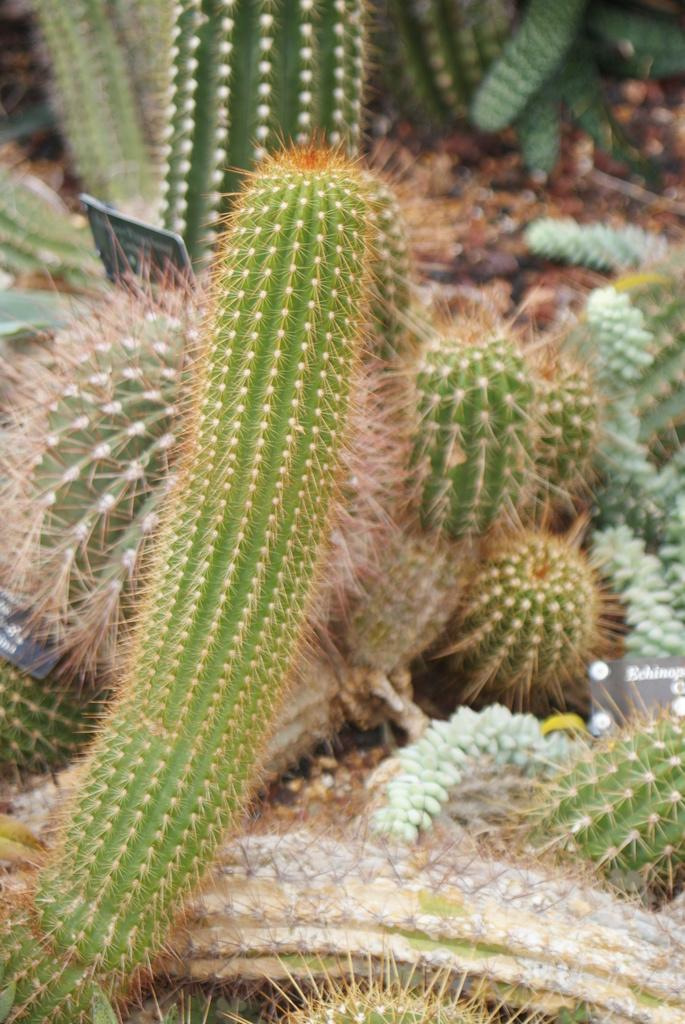What type of plants are in the image? There are cactus plants in the image. What else can be seen in the image besides the cactus plants? There is a small board with some text in the image. What type of soap is being used to clean the cactus plants in the image? There is no soap or cleaning activity depicted in the image; it only shows cactus plants and a small board with text. 